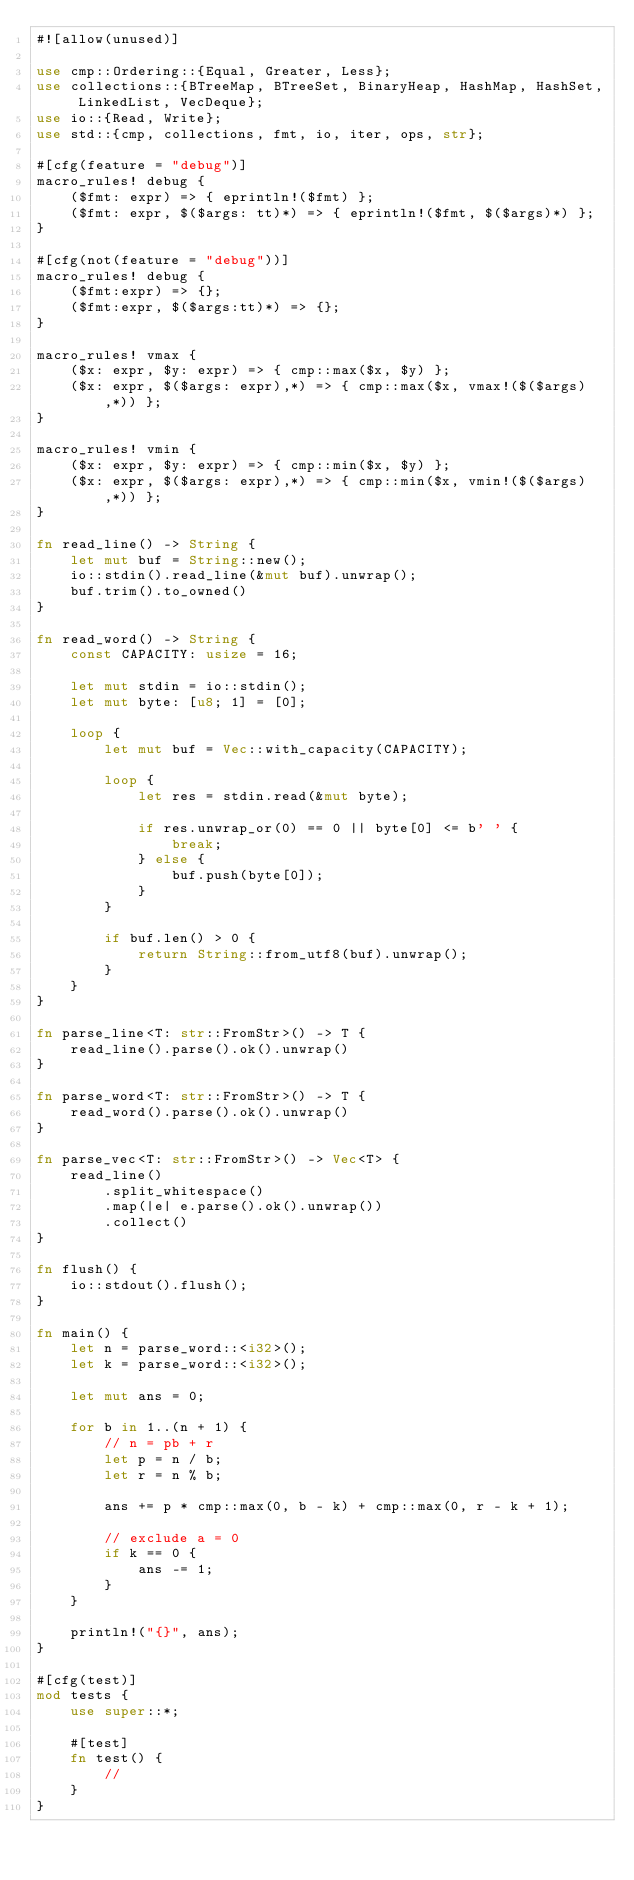<code> <loc_0><loc_0><loc_500><loc_500><_Rust_>#![allow(unused)]

use cmp::Ordering::{Equal, Greater, Less};
use collections::{BTreeMap, BTreeSet, BinaryHeap, HashMap, HashSet, LinkedList, VecDeque};
use io::{Read, Write};
use std::{cmp, collections, fmt, io, iter, ops, str};

#[cfg(feature = "debug")]
macro_rules! debug {
    ($fmt: expr) => { eprintln!($fmt) };
    ($fmt: expr, $($args: tt)*) => { eprintln!($fmt, $($args)*) };
}

#[cfg(not(feature = "debug"))]
macro_rules! debug {
    ($fmt:expr) => {};
    ($fmt:expr, $($args:tt)*) => {};
}

macro_rules! vmax {
    ($x: expr, $y: expr) => { cmp::max($x, $y) };
    ($x: expr, $($args: expr),*) => { cmp::max($x, vmax!($($args),*)) };
}

macro_rules! vmin {
    ($x: expr, $y: expr) => { cmp::min($x, $y) };
    ($x: expr, $($args: expr),*) => { cmp::min($x, vmin!($($args),*)) };
}

fn read_line() -> String {
    let mut buf = String::new();
    io::stdin().read_line(&mut buf).unwrap();
    buf.trim().to_owned()
}

fn read_word() -> String {
    const CAPACITY: usize = 16;

    let mut stdin = io::stdin();
    let mut byte: [u8; 1] = [0];

    loop {
        let mut buf = Vec::with_capacity(CAPACITY);

        loop {
            let res = stdin.read(&mut byte);

            if res.unwrap_or(0) == 0 || byte[0] <= b' ' {
                break;
            } else {
                buf.push(byte[0]);
            }
        }

        if buf.len() > 0 {
            return String::from_utf8(buf).unwrap();
        }
    }
}

fn parse_line<T: str::FromStr>() -> T {
    read_line().parse().ok().unwrap()
}

fn parse_word<T: str::FromStr>() -> T {
    read_word().parse().ok().unwrap()
}

fn parse_vec<T: str::FromStr>() -> Vec<T> {
    read_line()
        .split_whitespace()
        .map(|e| e.parse().ok().unwrap())
        .collect()
}

fn flush() {
    io::stdout().flush();
}

fn main() {
    let n = parse_word::<i32>();
    let k = parse_word::<i32>();

    let mut ans = 0;

    for b in 1..(n + 1) {
        // n = pb + r
        let p = n / b;
        let r = n % b;

        ans += p * cmp::max(0, b - k) + cmp::max(0, r - k + 1);

        // exclude a = 0
        if k == 0 {
            ans -= 1;
        }
    }

    println!("{}", ans);
}

#[cfg(test)]
mod tests {
    use super::*;

    #[test]
    fn test() {
        //
    }
}
</code> 